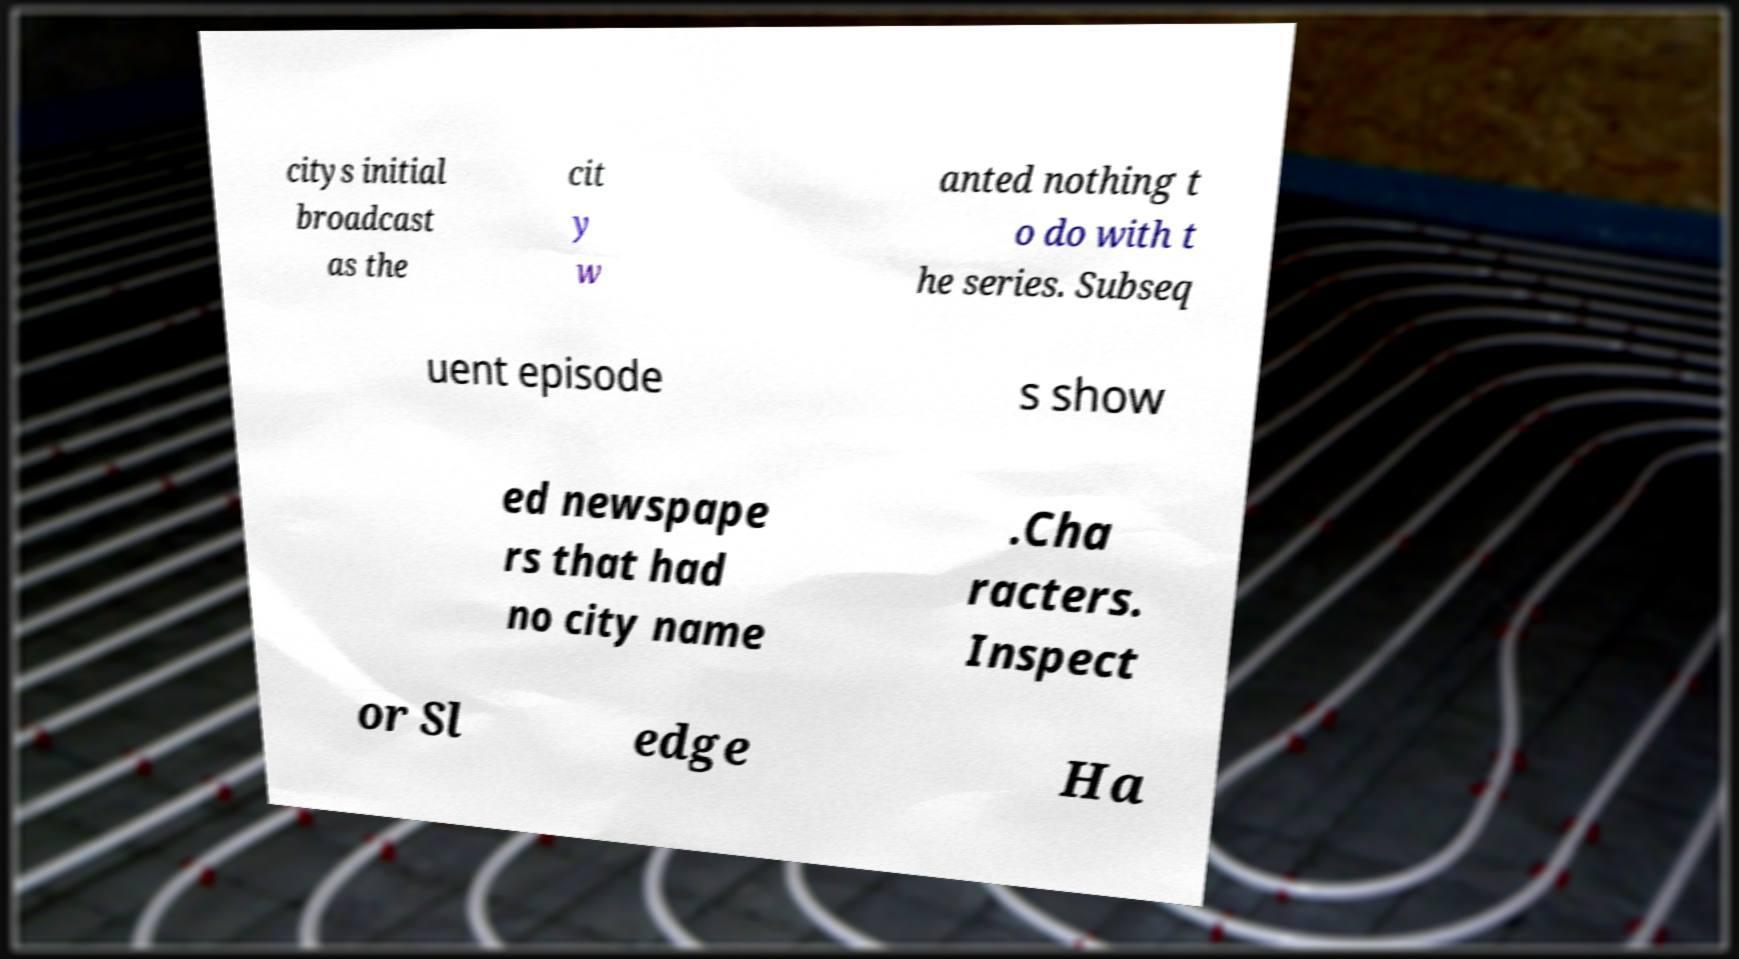Could you assist in decoding the text presented in this image and type it out clearly? citys initial broadcast as the cit y w anted nothing t o do with t he series. Subseq uent episode s show ed newspape rs that had no city name .Cha racters. Inspect or Sl edge Ha 